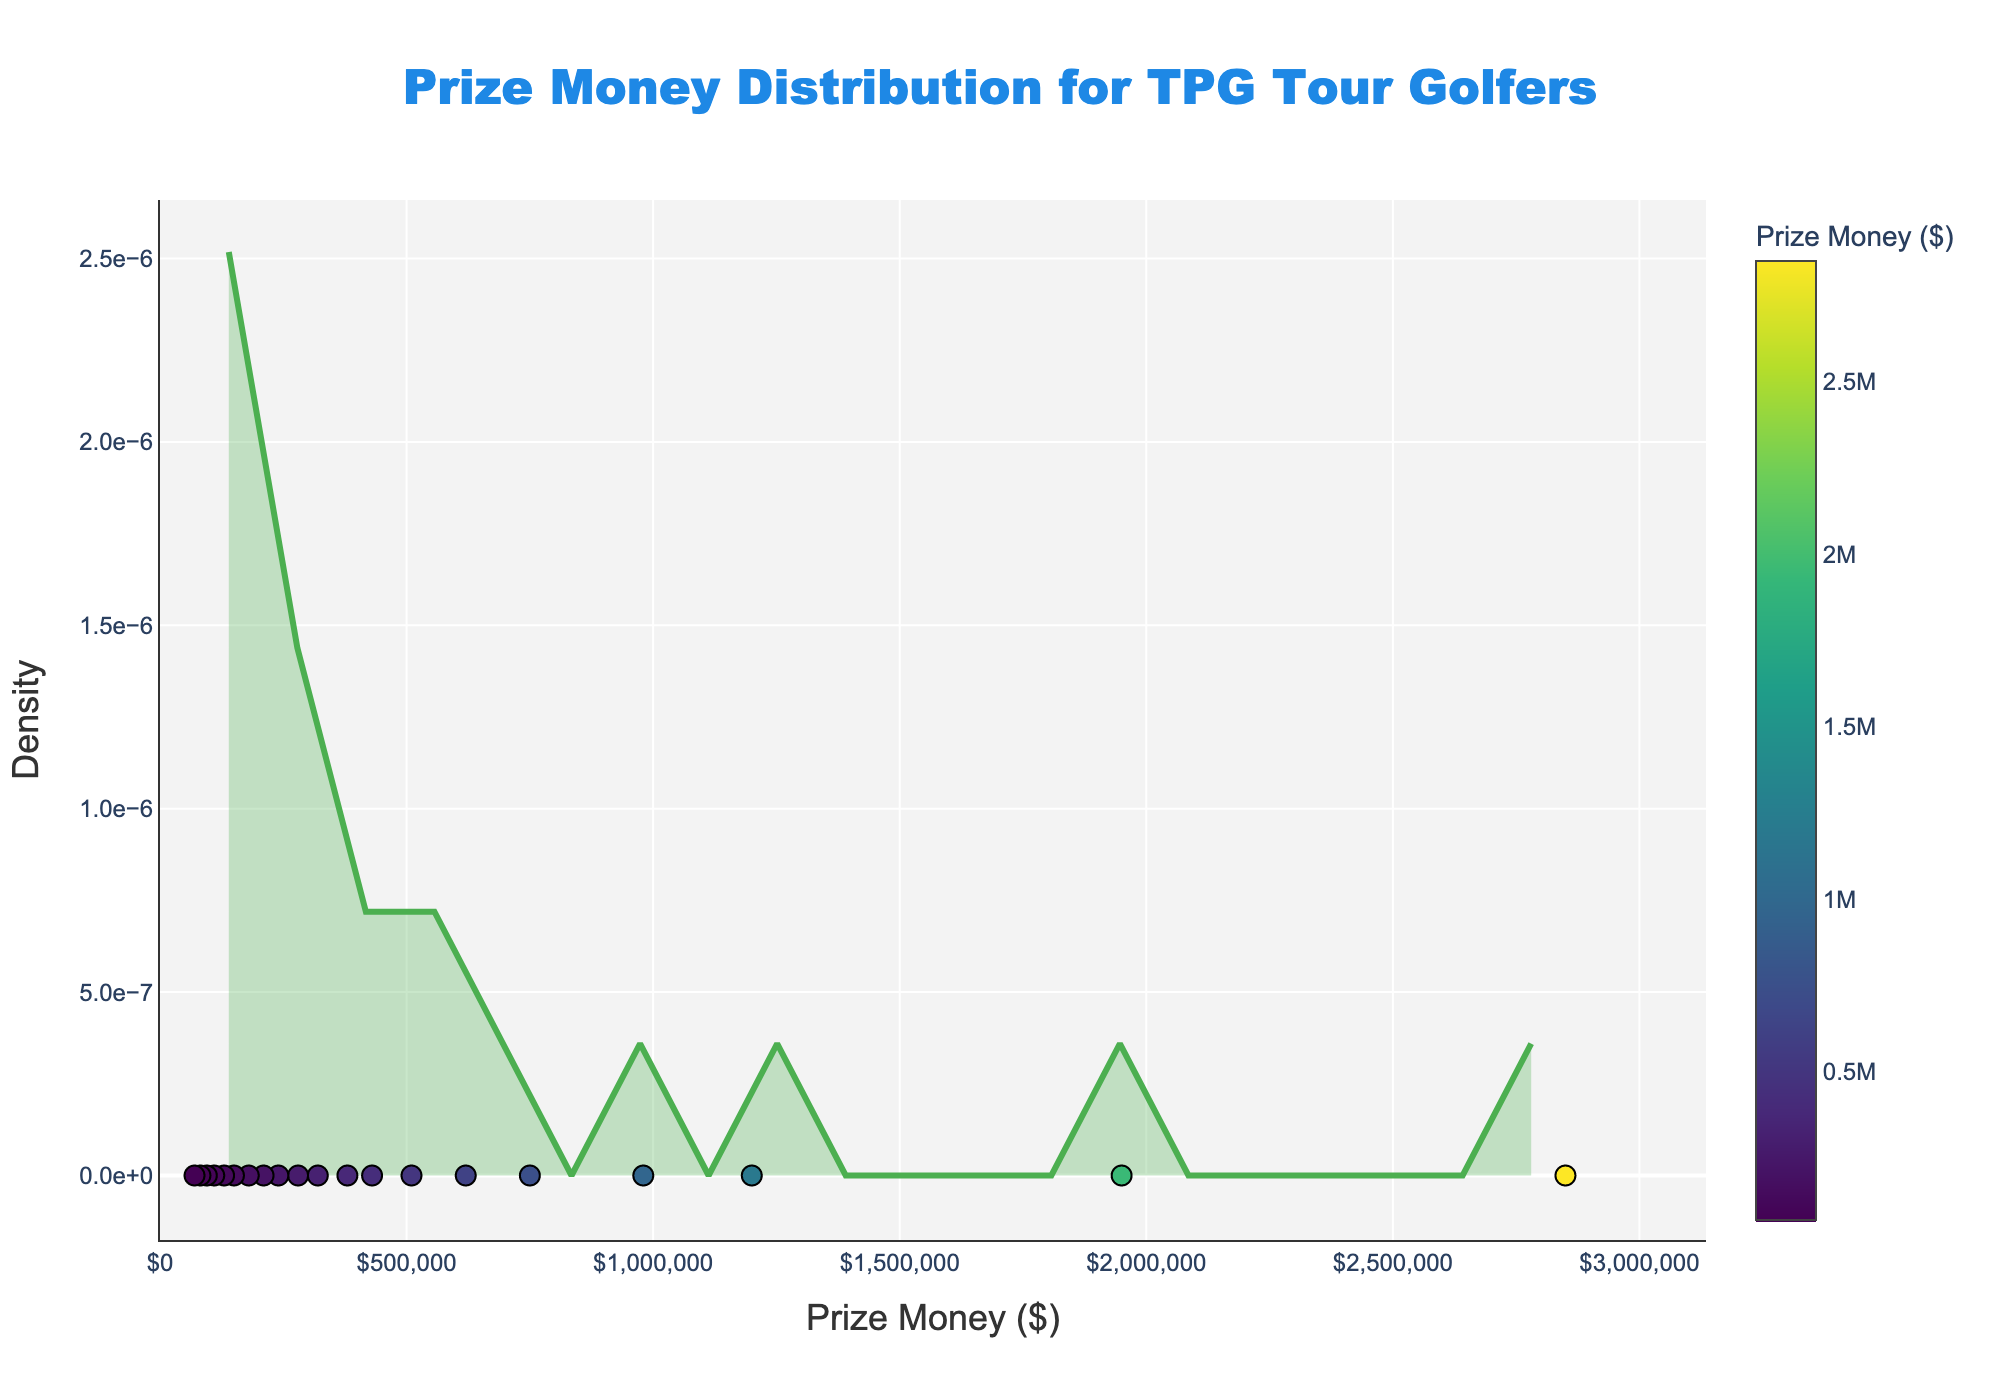What is the main title of the plot? The main title is prominently placed at the top center of the plot. It is usually in large, bold font to stand out. Look at the text at the top center of the plot.
Answer: Prize Money Distribution for TPG Tour Golfers What does the x-axis represent? The x-axis is usually labeled to indicate what is being measured horizontally across the plot. Look at the label below the horizontal axis.
Answer: Prize Money ($) How does the y-axis label read? The y-axis label explains what is being measured vertically. Look at the label next to the vertical axis.
Answer: Density What is the highest prize money value shown in the plot? Look at the highest value visible on the x-axis's scale. This is the maximum value of the prize money displayed on the plot.
Answer: 3,135,000 Approximately how many golfers earned less than $500,000? Refer to the density curve and identify the section where the x-axis values are less than $500,000. Count the number of data points (markers) below that threshold.
Answer: 6 Around what prize money value does the highest density of golfers occur? Look for the peak of the density curve, which indicates where the concentration of golf earnings is the highest.
Answer: Around $1,200,000 How does Angel Cabrera's prize money compare to the average prize money of all golfers in the plot? To find the average, sum up all the prize money values and divide by the number of golfers. Compare Angel Cabrera’s Prize Money to this average.
Answer: Higher Which golfer has the least prize money, and how much is it? Identify the data point on the x-axis that represents the lowest prize money value. The name of the golfer associated with this value corresponds to the data label or marker.
Answer: Martin Contini, $70,000 What is the spread of the middle 50% of golfers in terms of prize money? This involves identifying the interquartile range (IQR) on the x-axis, which gives the range within which the middle 50% of the data points lie.
Answer: About $320,000 to $1,200,000 How are the markers (representing golfers) visually differentiated in the plot? Observe the markers on the plot. They often vary by size, color, or presence of a color scale to differentiate the data points.
Answer: By color and size, with a color scale and outlines 